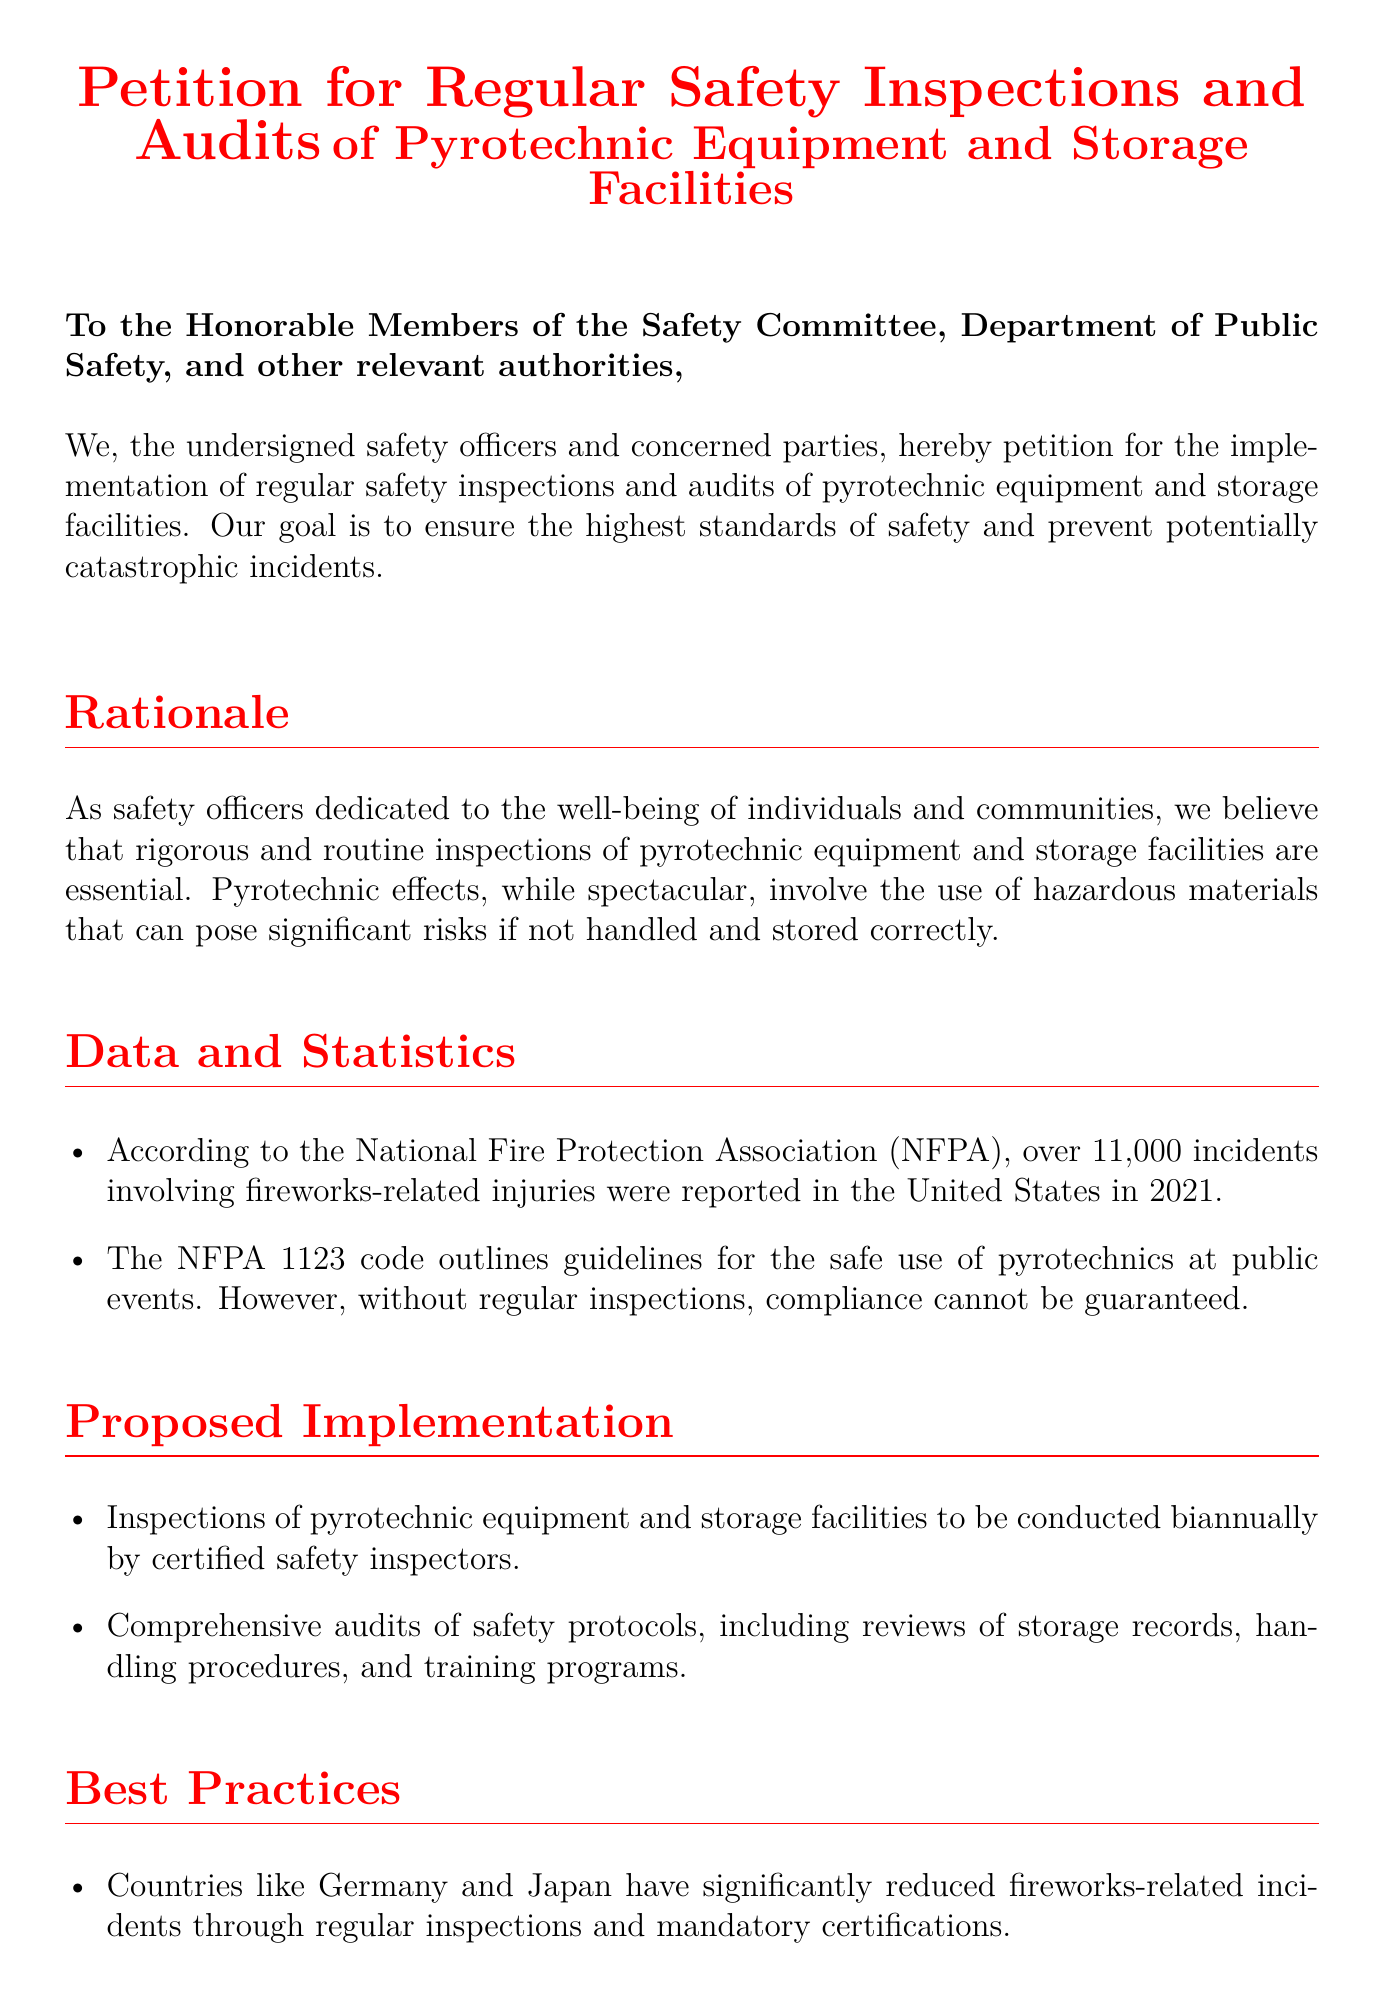What is the title of the petition? The title of the petition is a declaration of the purpose, which is to request regular safety inspections and audits.
Answer: Petition for Regular Safety Inspections and Audits How many incidents involving fireworks-related injuries were reported in 2021? The document states a specific number of incidents to highlight safety concerns.
Answer: 11,000 What frequency of inspections is proposed for the pyrotechnic equipment? The document explicitly mentions the frequency for conducting inspections as per the proposed implementation section.
Answer: Biannually Which organizations have successfully reduced fireworks-related incidents? This question pertains to examples provided in the document to show effective practices from other countries.
Answer: Germany and Japan What does NFPA stand for? The abbreviation NFPA is mentioned in the document, which refers to an organization related to fire safety.
Answer: National Fire Protection Association What is the purpose of the proposed inspections according to the document? The purpose is specifically stated in the rationale section, focusing on safety and prevention.
Answer: Ensure the highest standards of safety Who is the intended audience of the petition? The introductory section mentions the specific parties being addressed by the petition.
Answer: Honorable Members of the Safety Committee What color is used predominantly for the title text? The document specifies the color used for the title, which is a distinctive safety color.
Answer: Safety red 